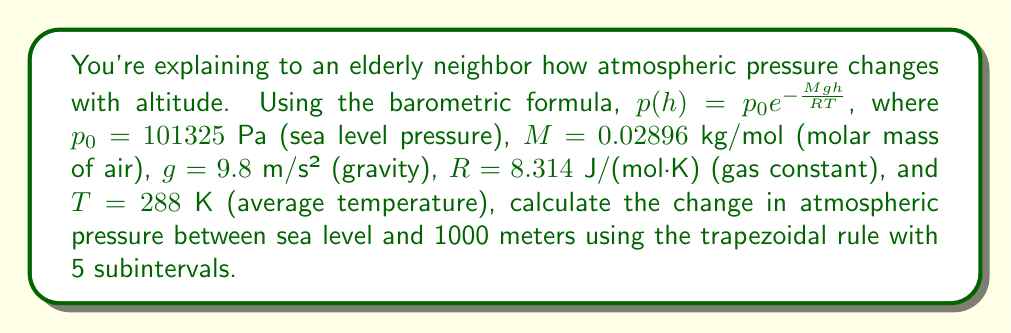Could you help me with this problem? To solve this problem, we'll use the trapezoidal rule for numerical integration:

1) First, we need to set up the integral. The change in pressure is:
   $$\Delta p = \int_0^{1000} -\frac{d}{dh}(p_0e^{-\frac{Mgh}{RT}}) dh = \int_0^{1000} \frac{Mgp_0}{RT}e^{-\frac{Mgh}{RT}} dh$$

2) Let's define $f(h) = \frac{Mgp_0}{RT}e^{-\frac{Mgh}{RT}}$

3) For 5 subintervals, we need to evaluate $f(h)$ at $h = 0, 200, 400, 600, 800, 1000$ meters:

   $f(0) = 11.796$
   $f(200) = 11.561$
   $f(400) = 11.331$
   $f(600) = 11.105$
   $f(800) = 10.884$
   $f(1000) = 10.667$

4) Apply the trapezoidal rule:
   $$\Delta p \approx \frac{1000-0}{2(5)}[f(0) + 2f(200) + 2f(400) + 2f(600) + 2f(800) + f(1000)]$$

5) Substitute the values:
   $$\Delta p \approx 100[11.796 + 2(11.561 + 11.331 + 11.105 + 10.884) + 10.667]$$

6) Calculate:
   $$\Delta p \approx 11332.8 \text{ Pa}$$
Answer: 11332.8 Pa 